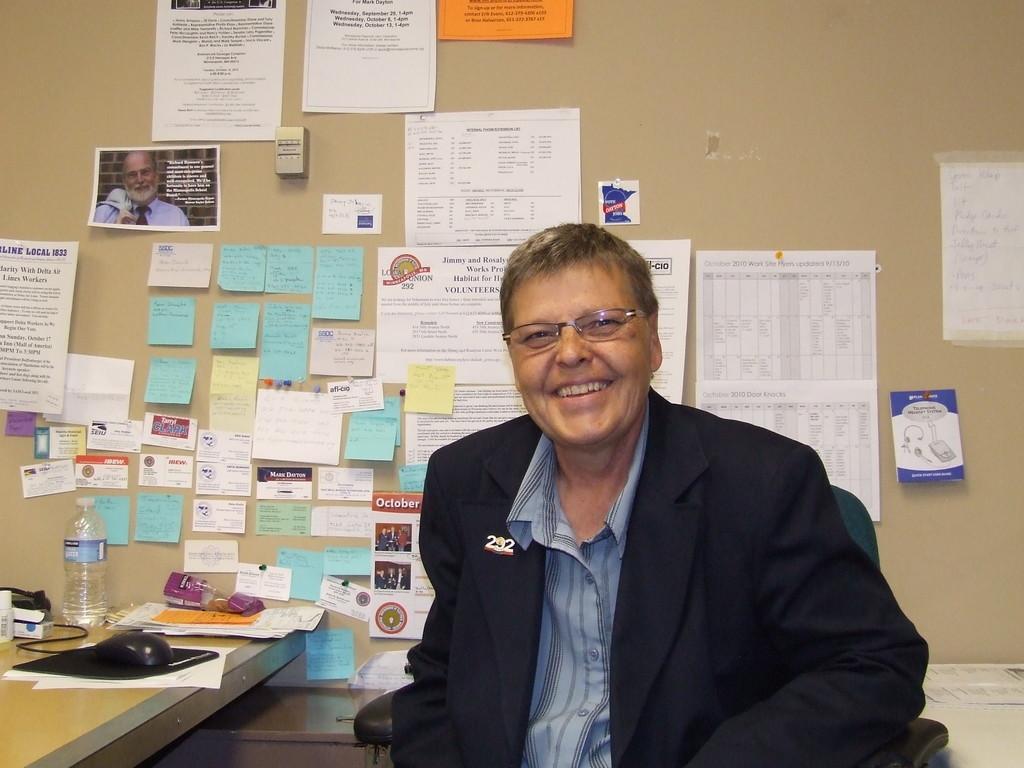Could you give a brief overview of what you see in this image? In this image there is a man sitting in the chair in the back ground there is a table , mouse ,bottle , papers , sticky notes stick to the wall. 